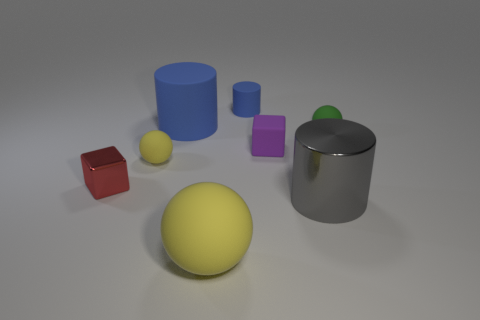Do the small rubber object that is on the right side of the gray metal object and the big metal cylinder have the same color?
Keep it short and to the point. No. There is a matte thing that is the same color as the large rubber ball; what shape is it?
Your response must be concise. Sphere. What number of green spheres have the same material as the purple cube?
Give a very brief answer. 1. There is a big yellow thing; how many purple blocks are left of it?
Provide a succinct answer. 0. How big is the red metal object?
Make the answer very short. Small. There is a cylinder that is the same size as the purple rubber thing; what is its color?
Offer a very short reply. Blue. Is there another metallic object that has the same color as the big metal thing?
Make the answer very short. No. What is the purple block made of?
Your answer should be compact. Rubber. What number of purple cubes are there?
Provide a short and direct response. 1. There is a big rubber thing that is in front of the green rubber ball; is its color the same as the large cylinder in front of the tiny metallic object?
Your response must be concise. No. 